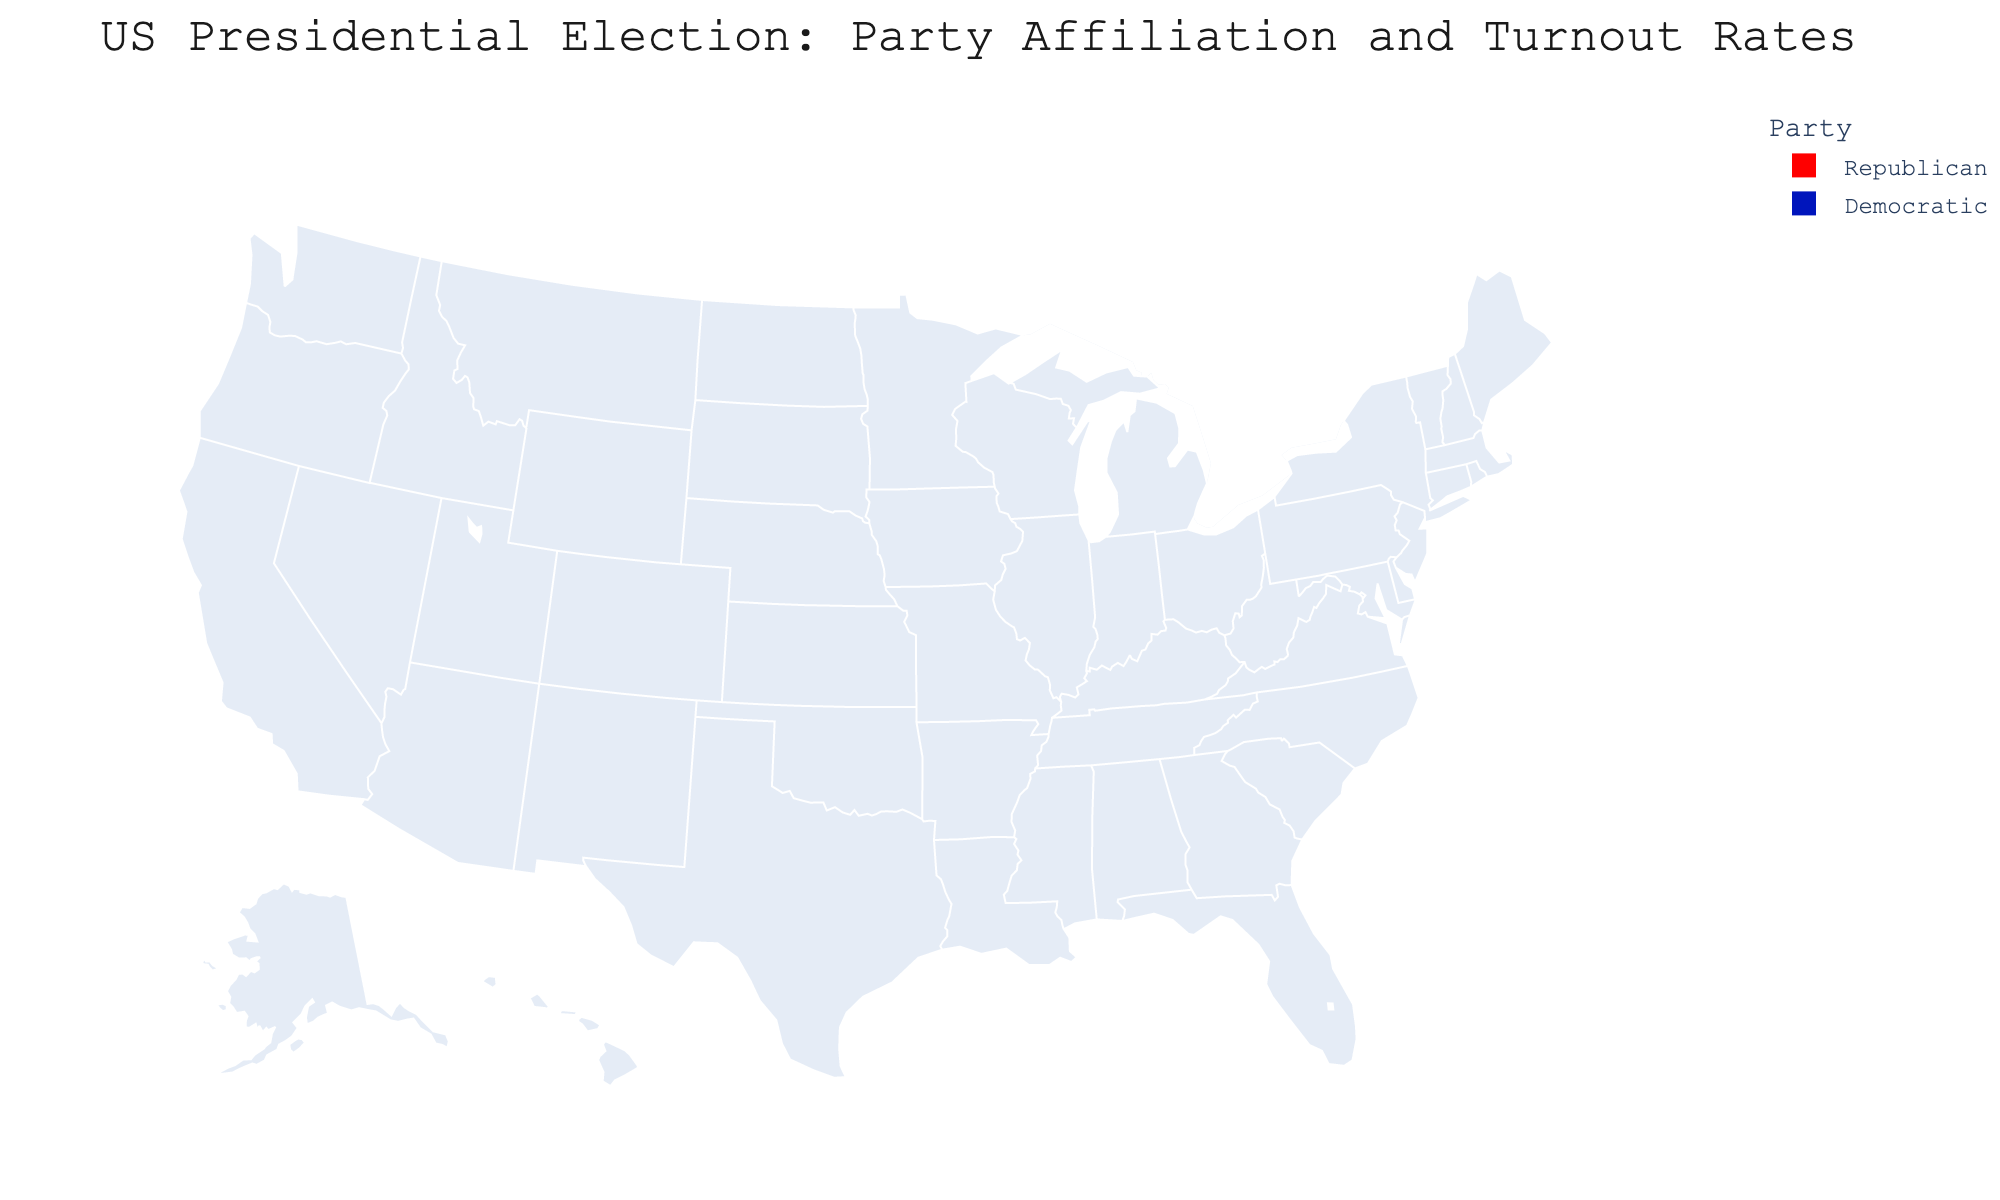what is the party affiliation of Florida? To determine Florida's party affiliation, look at the color of Florida on the map. Florida is colored red, which corresponds to Republican.
Answer: Republican what's the highest turnout rate among the states? To identify the highest turnout rate, look at the hover data on the map. Wisconsin has the highest turnout rate at 72.3%.
Answer: Wisconsin compare the electoral votes of Georgia and North Carolina, which state has more electoral votes? Georgia and North Carolina's electoral votes are indicated in the hover data. Georgia has 16 electoral votes, and North Carolina has 15 electoral votes. Thus, Georgia has more electoral votes.
Answer: Georgia what's the average turnout rate of Democratic states? To find the average, extract each Democratic state's turnout and sum them, then divide by the number of Democratic states. (70.2 + 68.1 + 67.7 + 71.5 + 72.3 + 76.4 + 75.6 + 76.3) / 8 = 72.52.
Answer: 72.52 list the states with a turnout rate above 70% Hover over each state to find the ones with a turnout rate above 70%. These states are Pennsylvania (70.2%), North Carolina (69.3%), Virginia (71.5%), Wisconsin (72.3%), Colorado (76.4%), New Hampshire (75.6%), and Maine (76.3%).
Answer: Pennsylvania, North Carolina, Virginia, Wisconsin, Colorado, New Hampshire, Maine how many Republican states have a turnout rate below 70%? Scan the Republican states (Florida, Ohio, North Carolina, and Iowa) and check their turnout rates. Florida (65.8%) and Ohio (67.4%) have a turnout rate below 70%. There are two such states.
Answer: 2 which Democratic state has the fewest electoral votes? Look at the electoral votes of each Democratic state. Nevada has the fewest with 6 electoral votes.
Answer: Nevada are there more states with Democratic or Republican party affiliation? Count the Democratic and Republican states. There are 9 Democratic states (Pennsylvania, Michigan, Georgia, Virginia, Wisconsin, Colorado, Arizona, New Hampshire, Maine) and 5 Republican states (Florida, Ohio, North Carolina, Iowa). There are more Democratic states.
Answer: Democratic which state has the lowest turnout rate? Identify the state with the lowest turnout rate by looking at each state's hover data. Nevada has the lowest turnout rate at 64.8%.
Answer: Nevada 